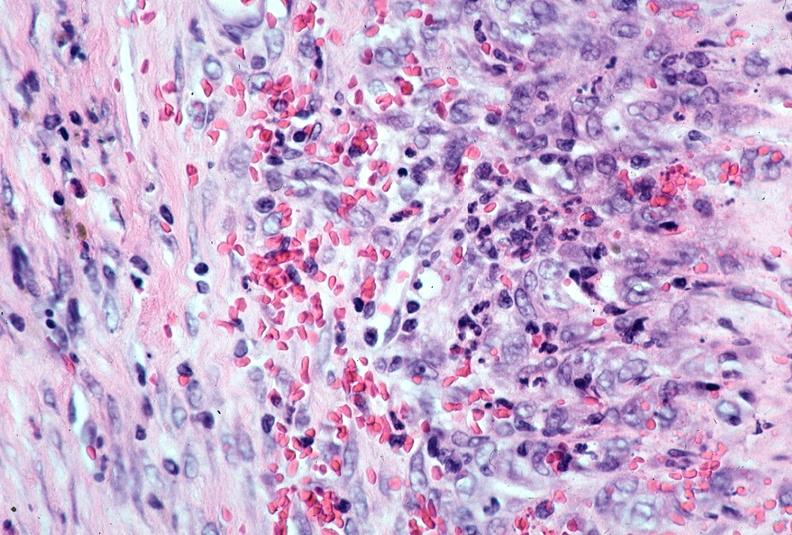s cardiovascular present?
Answer the question using a single word or phrase. Yes 